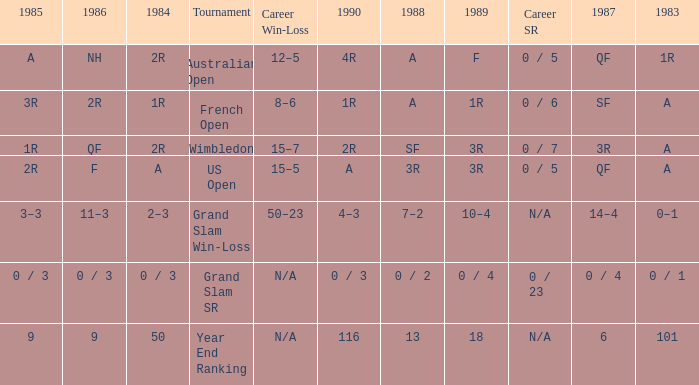What is the result in 1985 when the career win-loss is n/a, and 0 / 23 as the career SR? 0 / 3. 